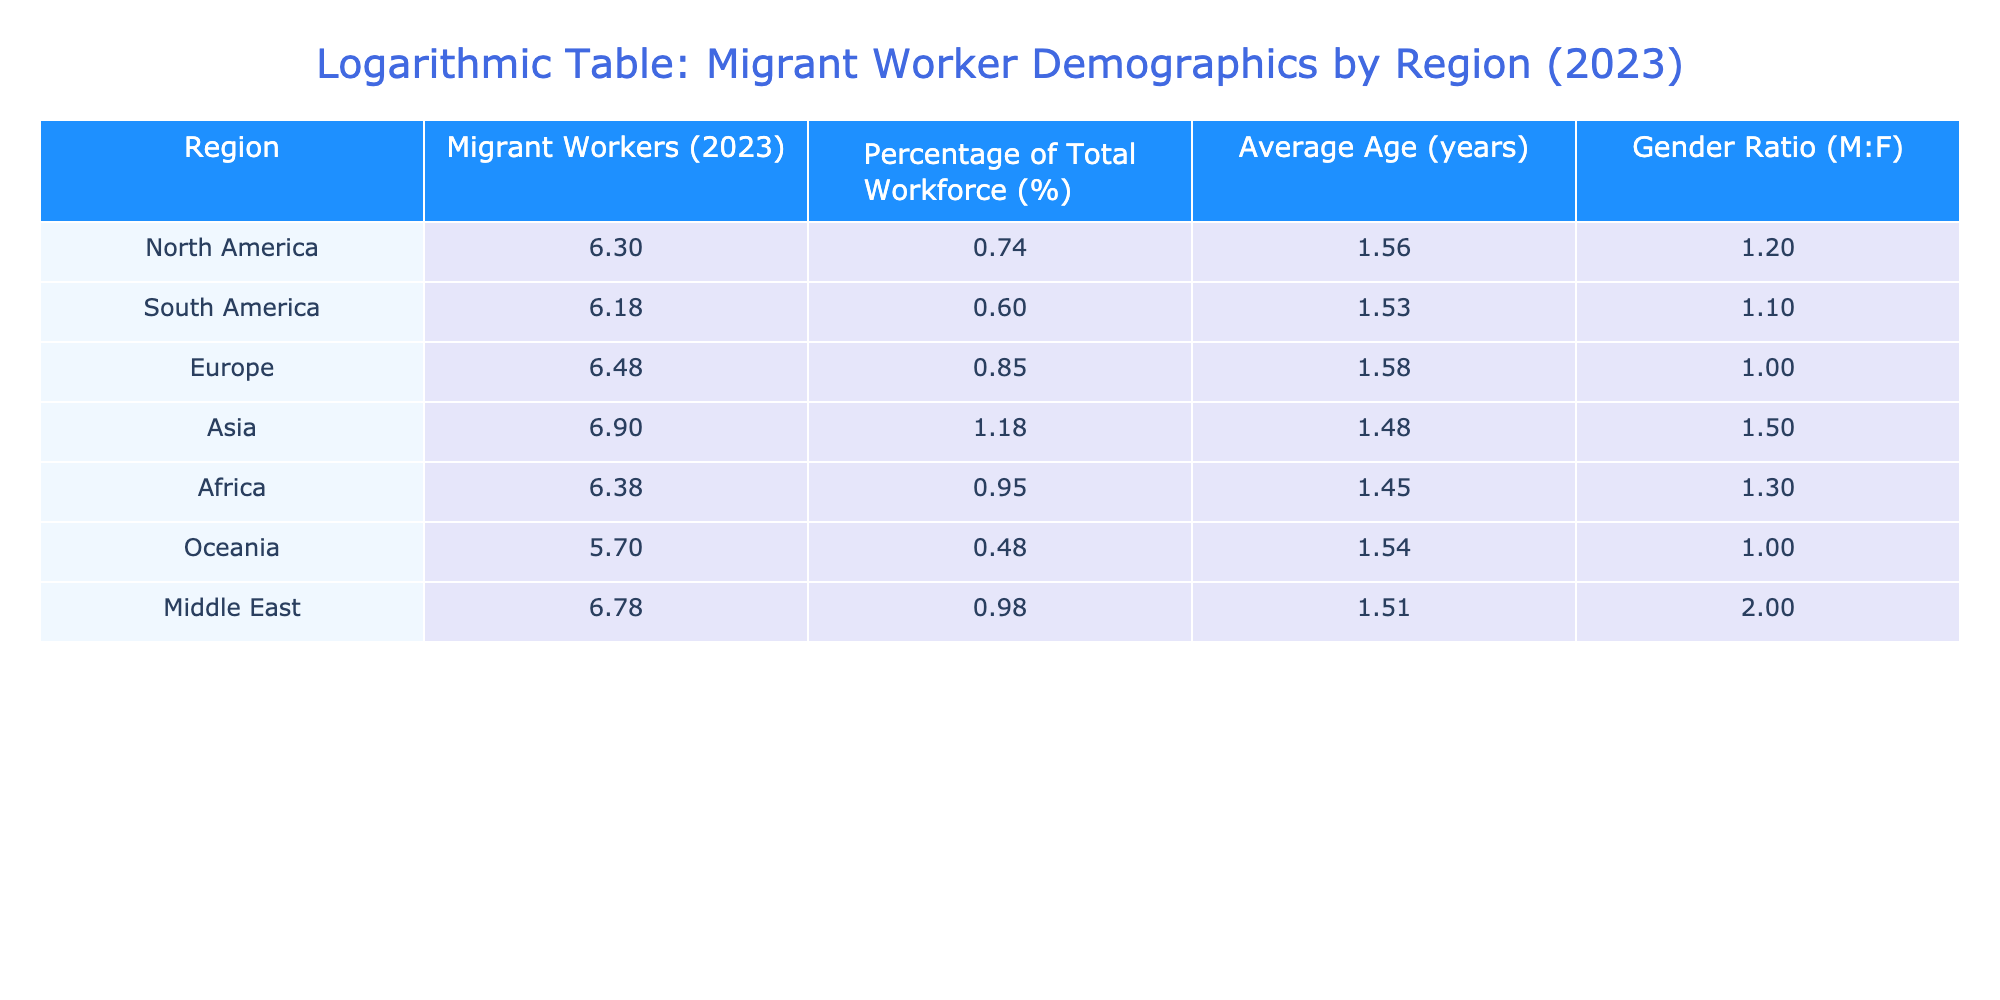What is the percentage of the total workforce in Asia? The table indicates the percentage of the total workforce for each region. Looking at the Asia row, the value listed is 15.0%.
Answer: 15.0% Which region has the highest average age of migrant workers? By examining the 'Average Age (years)' column, we see that Europe has the highest value at 38 years compared to other regions.
Answer: Europe What is the total number of migrant workers represented in the table? To find the total, sum the 'Migrant Workers (2023)' values from all regions: 2000000 + 1500000 + 3000000 + 8000000 + 2400000 + 500000 + 6000000 = 18500000.
Answer: 18500000 Is the gender ratio in the Middle East above 1.5? Looking at the 'Gender Ratio (M:F)' column, the value for the Middle East is 2.0, which is indeed above 1.5.
Answer: Yes Calculate the average number of migrant workers across all regions. To find the average, first sum the number of migrant workers: 2000000 + 1500000 + 3000000 + 8000000 + 2400000 + 500000 + 6000000 = 18500000. Since there are 7 regions, the average is 18500000 / 7 ≈ 2642857.14.
Answer: 2642857.14 Which region has the lowest percentage of total workforce? By inspecting the 'Percentage of Total Workforce (%)' column, we see Oceania has the lowest percentage at 3.0%.
Answer: Oceania Do more than 50% of migrant workers come from Africa and Asia combined? Adding the number of migrant workers in Africa (2400000) and Asia (8000000), we get 2400000 + 8000000 = 10400000. The total number of migrant workers is 18500000, and 10400000 is indeed more than 50% of that.
Answer: Yes What is the difference in the average age between migrant workers in Europe and those in Africa? The average age for Europe is 38 years and for Africa is 28 years. The difference is 38 - 28 = 10 years.
Answer: 10 years 